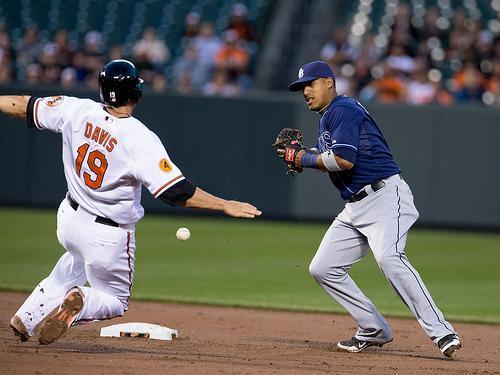How many people wearing a helmet?
Give a very brief answer. 1. 